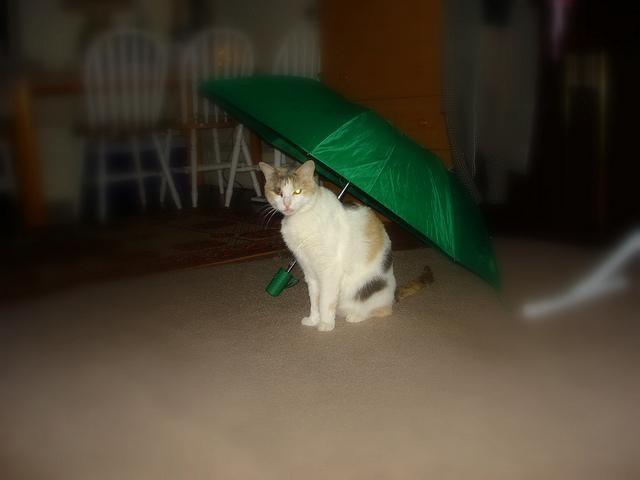How many chairs are visible?
Give a very brief answer. 3. 